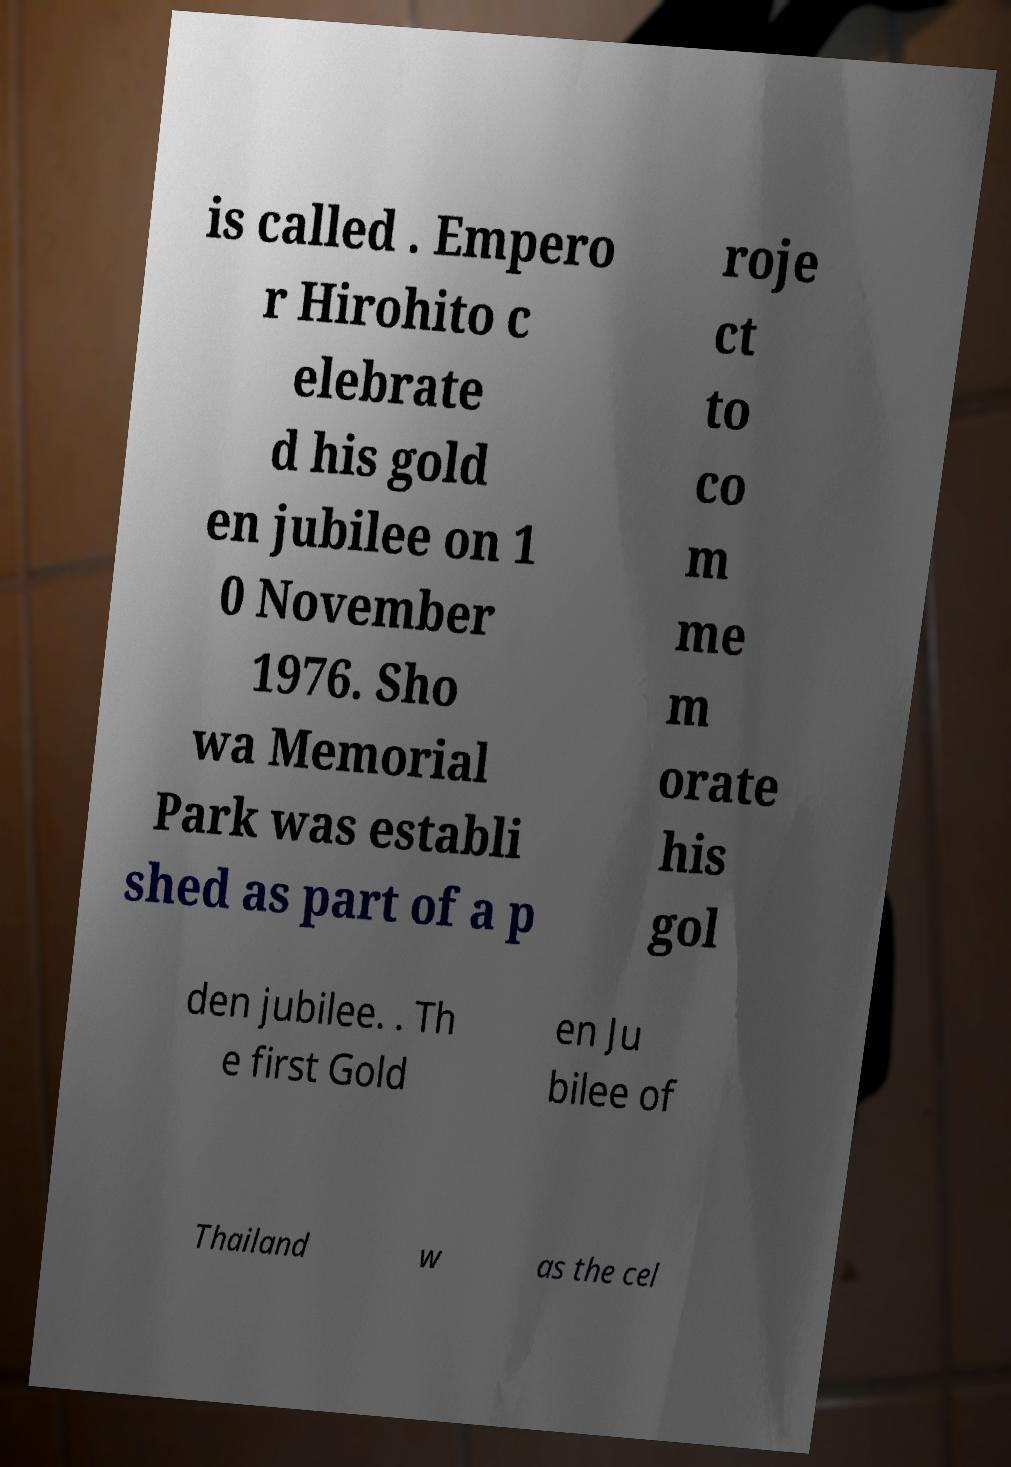There's text embedded in this image that I need extracted. Can you transcribe it verbatim? is called . Empero r Hirohito c elebrate d his gold en jubilee on 1 0 November 1976. Sho wa Memorial Park was establi shed as part of a p roje ct to co m me m orate his gol den jubilee. . Th e first Gold en Ju bilee of Thailand w as the cel 